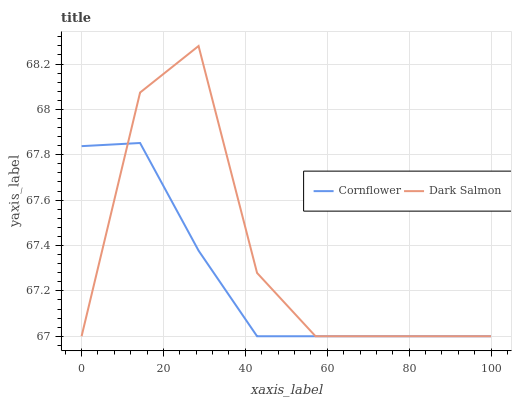Does Cornflower have the minimum area under the curve?
Answer yes or no. Yes. Does Dark Salmon have the maximum area under the curve?
Answer yes or no. Yes. Does Dark Salmon have the minimum area under the curve?
Answer yes or no. No. Is Cornflower the smoothest?
Answer yes or no. Yes. Is Dark Salmon the roughest?
Answer yes or no. Yes. Is Dark Salmon the smoothest?
Answer yes or no. No. Does Dark Salmon have the highest value?
Answer yes or no. Yes. Does Dark Salmon intersect Cornflower?
Answer yes or no. Yes. Is Dark Salmon less than Cornflower?
Answer yes or no. No. Is Dark Salmon greater than Cornflower?
Answer yes or no. No. 